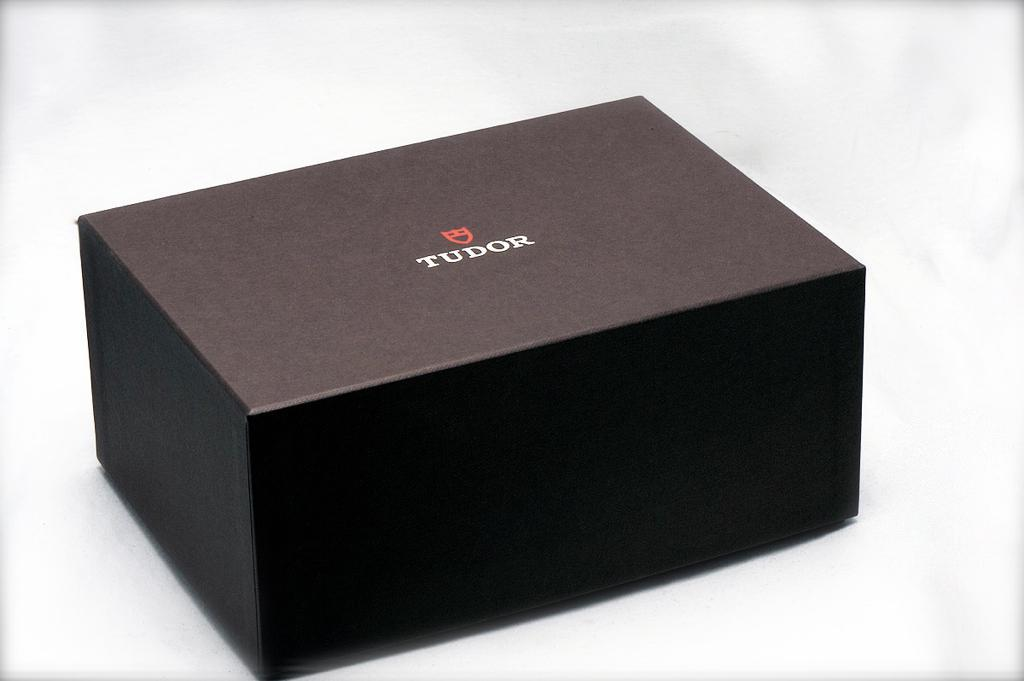Provide a one-sentence caption for the provided image. A small black box with the word Tudor on the lid. 